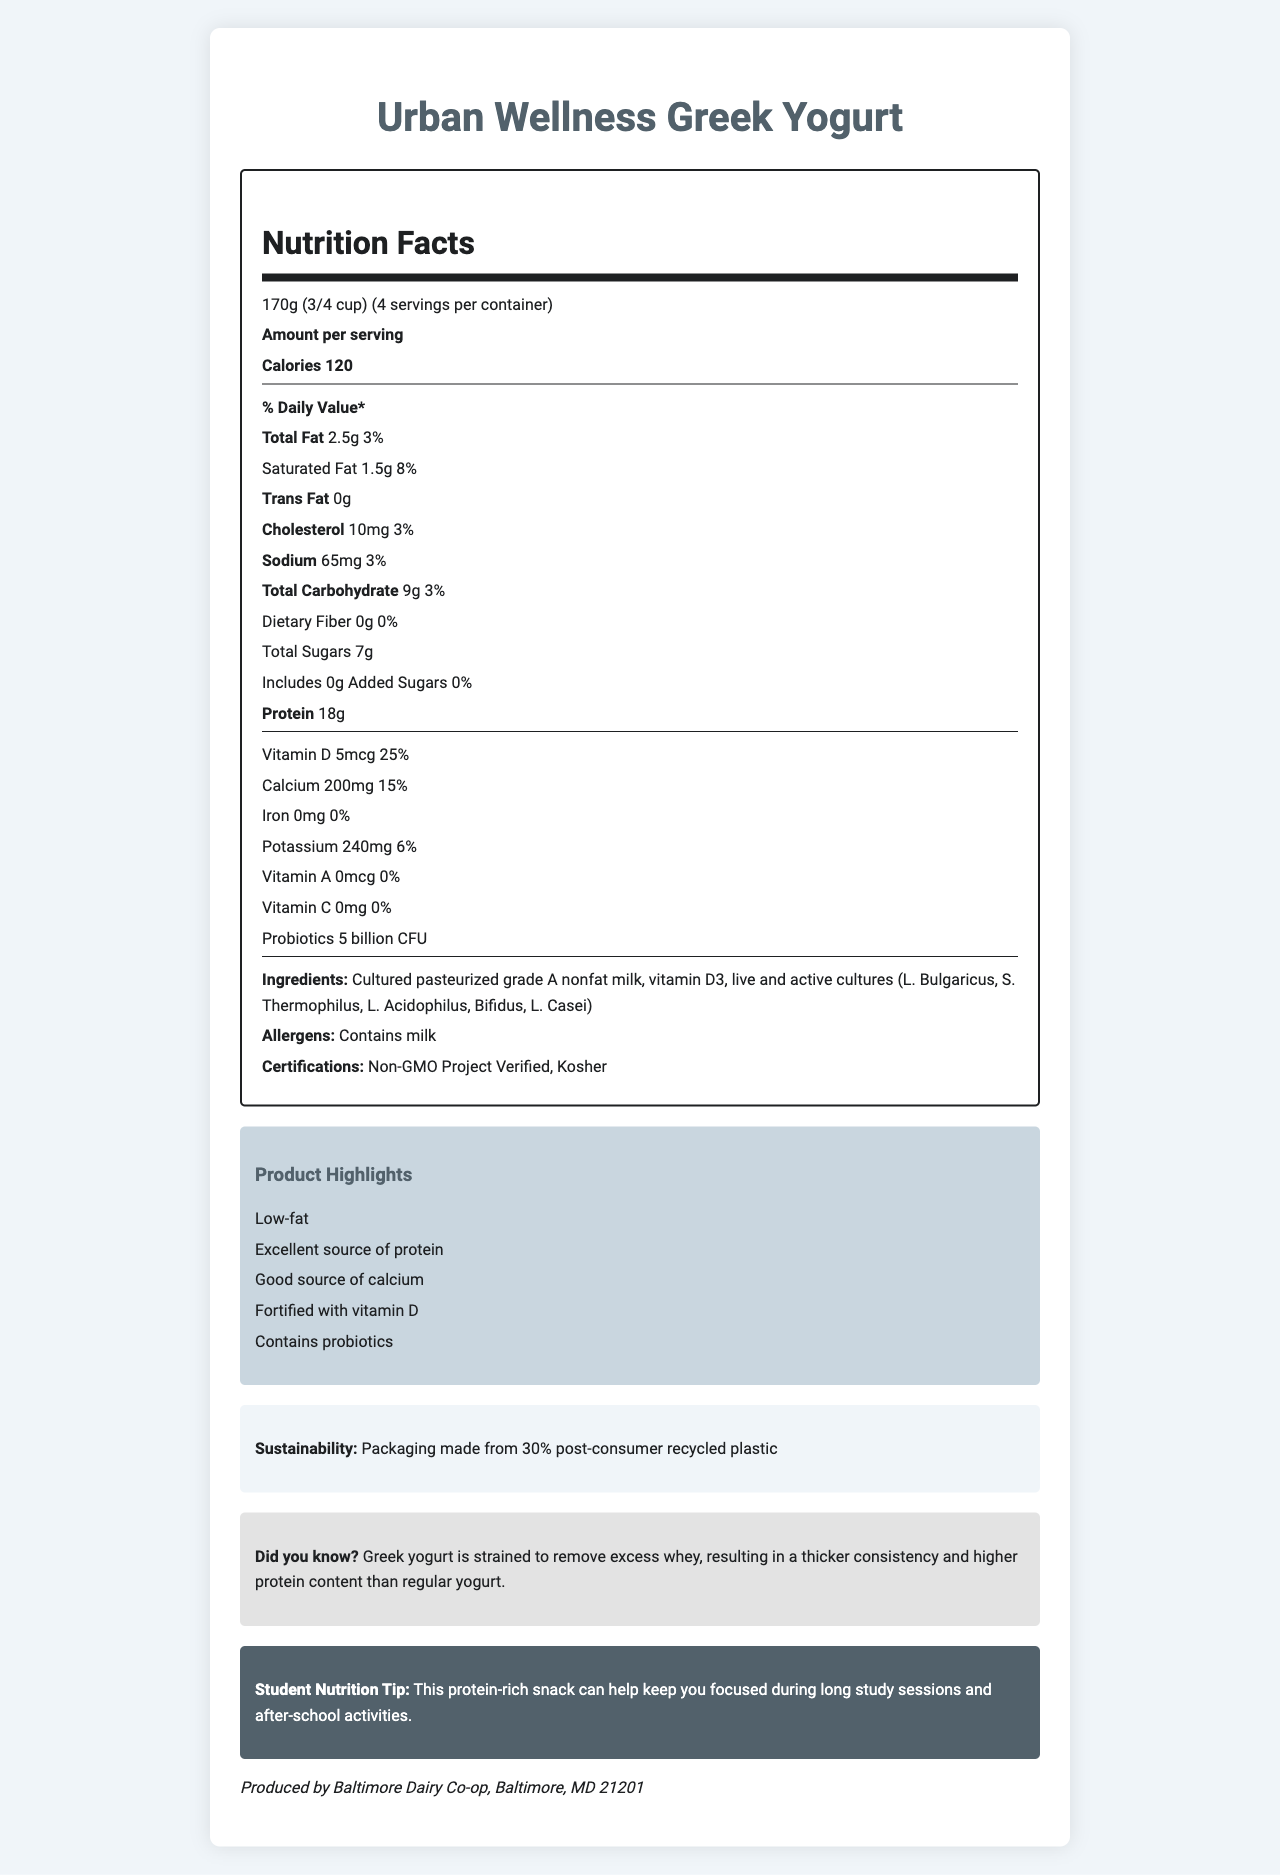what is the serving size? The serving size is listed at the top of the Nutrition Facts section.
Answer: 170g (3/4 cup) how many calories are in a serving of Urban Wellness Greek Yogurt? The calories per serving are clearly stated under the "Amount per serving" section.
Answer: 120 calories what is the percentage daily value of total fat per serving? The document lists the daily value for total fat as 3% for a 170g serving.
Answer: 3% how much protein is in one serving? The amount of protein per serving is listed as 18g in the Nutrition Facts section.
Answer: 18g what is the total sugar content in a serving? The document states that the total sugars content per serving is 7g.
Answer: 7g how much vitamin D is fortified in the yogurt? The document mentions that the yogurt contains 5mcg of vitamin D.
Answer: 5mcg what is the daily value percentage of calcium in one serving? The daily value percentage of calcium is listed as 15%.
Answer: 15% which company produces Urban Wellness Greek Yogurt? A. Baltimore Dairy Co-op B. Maryland Dairy Co-op C. Urban Wellness Co-op The manufacturer info states that the product is produced by Baltimore Dairy Co-op.
Answer: A how many servings are there per container? A. 2 B. 4 C. 6 D. 8 The servings per container are listed as 4 in the Nutrition Facts section.
Answer: B is the product certified kosher? Yes/No One of the certifications listed is "Kosher".
Answer: Yes what is the main idea of the document? The document contains sections on the product's nutritional data, ingredients, certifications, claims, and additional tips on sustainability, educational facts, and nutrition for students.
Answer: The document provides detailed Nutrition Facts, ingredients, certifications, and additional information about Urban Wellness Greek Yogurt, highlighting its health benefits, certifications, and sustainability information. how much sodium does a serving contain? The amount of sodium per serving is listed as 65mg in the Nutrition Facts section.
Answer: 65mg which live cultures are included in the yogurt? The ingredients list includes the types of live and active cultures present in the yogurt.
Answer: L. Bulgaricus, S. Thermophilus, L. Acidophilus, Bifidus, L. Casei what are the claims made about the product? The marketing claims section lists all these claims about the yogurt.
Answer: Low-fat, Excellent source of protein, Good source of calcium, Fortified with vitamin D, Contains probiotics 